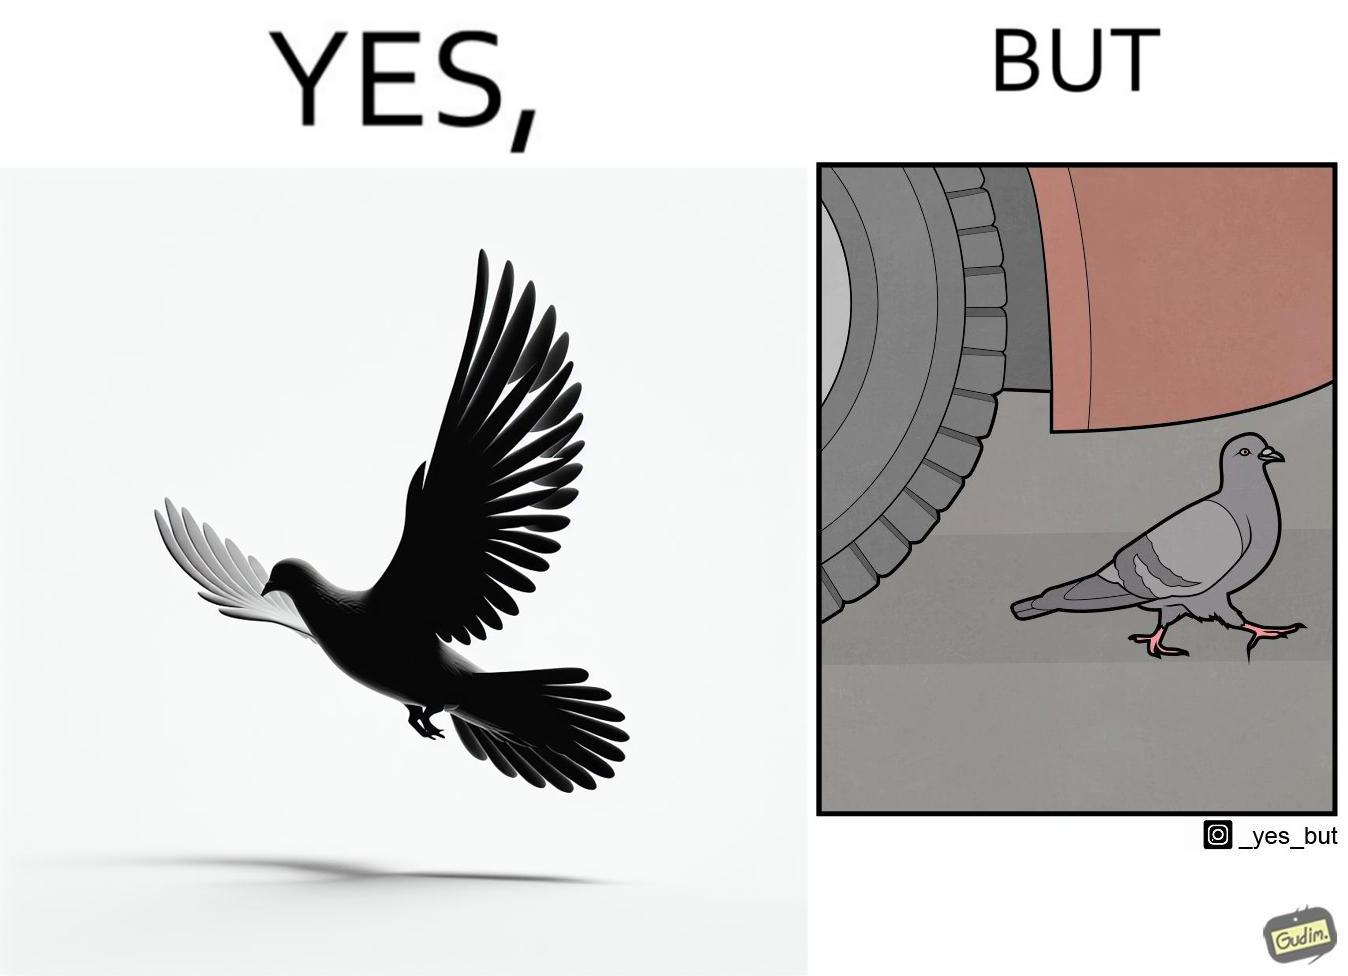What makes this image funny or satirical? The image is ironic, because even when the pigeon has wings to fly it is walking even when it seems threatening to its life 